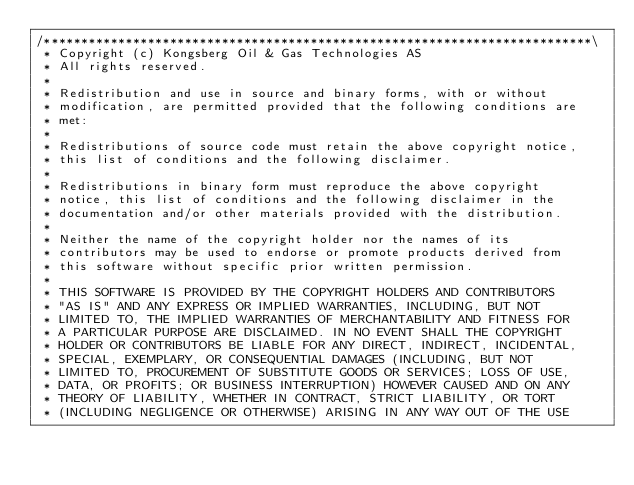<code> <loc_0><loc_0><loc_500><loc_500><_ObjectiveC_>/**************************************************************************\
 * Copyright (c) Kongsberg Oil & Gas Technologies AS
 * All rights reserved.
 * 
 * Redistribution and use in source and binary forms, with or without
 * modification, are permitted provided that the following conditions are
 * met:
 * 
 * Redistributions of source code must retain the above copyright notice,
 * this list of conditions and the following disclaimer.
 * 
 * Redistributions in binary form must reproduce the above copyright
 * notice, this list of conditions and the following disclaimer in the
 * documentation and/or other materials provided with the distribution.
 * 
 * Neither the name of the copyright holder nor the names of its
 * contributors may be used to endorse or promote products derived from
 * this software without specific prior written permission.
 * 
 * THIS SOFTWARE IS PROVIDED BY THE COPYRIGHT HOLDERS AND CONTRIBUTORS
 * "AS IS" AND ANY EXPRESS OR IMPLIED WARRANTIES, INCLUDING, BUT NOT
 * LIMITED TO, THE IMPLIED WARRANTIES OF MERCHANTABILITY AND FITNESS FOR
 * A PARTICULAR PURPOSE ARE DISCLAIMED. IN NO EVENT SHALL THE COPYRIGHT
 * HOLDER OR CONTRIBUTORS BE LIABLE FOR ANY DIRECT, INDIRECT, INCIDENTAL,
 * SPECIAL, EXEMPLARY, OR CONSEQUENTIAL DAMAGES (INCLUDING, BUT NOT
 * LIMITED TO, PROCUREMENT OF SUBSTITUTE GOODS OR SERVICES; LOSS OF USE,
 * DATA, OR PROFITS; OR BUSINESS INTERRUPTION) HOWEVER CAUSED AND ON ANY
 * THEORY OF LIABILITY, WHETHER IN CONTRACT, STRICT LIABILITY, OR TORT
 * (INCLUDING NEGLIGENCE OR OTHERWISE) ARISING IN ANY WAY OUT OF THE USE</code> 